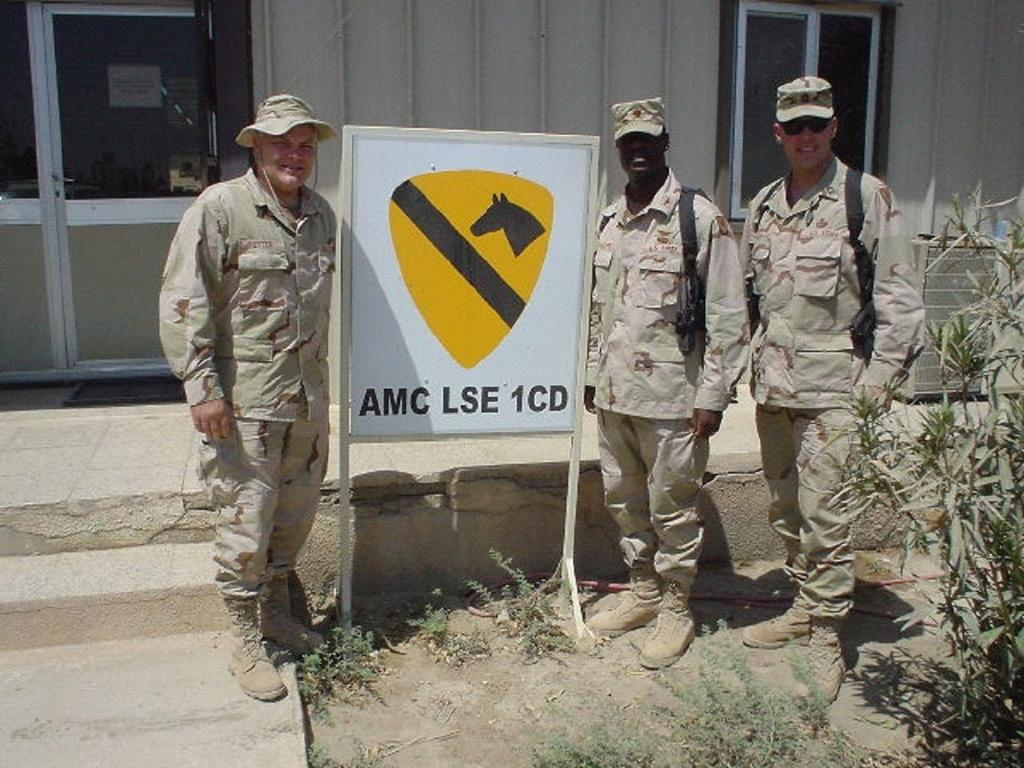How many people are standing in the image? There are three persons standing on the ground in the image. What are the persons standing near? The persons are standing at a board. What can be seen in the background of the image? There are doors, windows, objects, and a wall in the background of the image. What type of vegetation is present in the image? There are plants on the ground in the image. What type of wing can be seen flying in the image? There are no wings or flying creatures present in the image. What type of teeth can be seen in the image? There are no teeth visible in the image. 